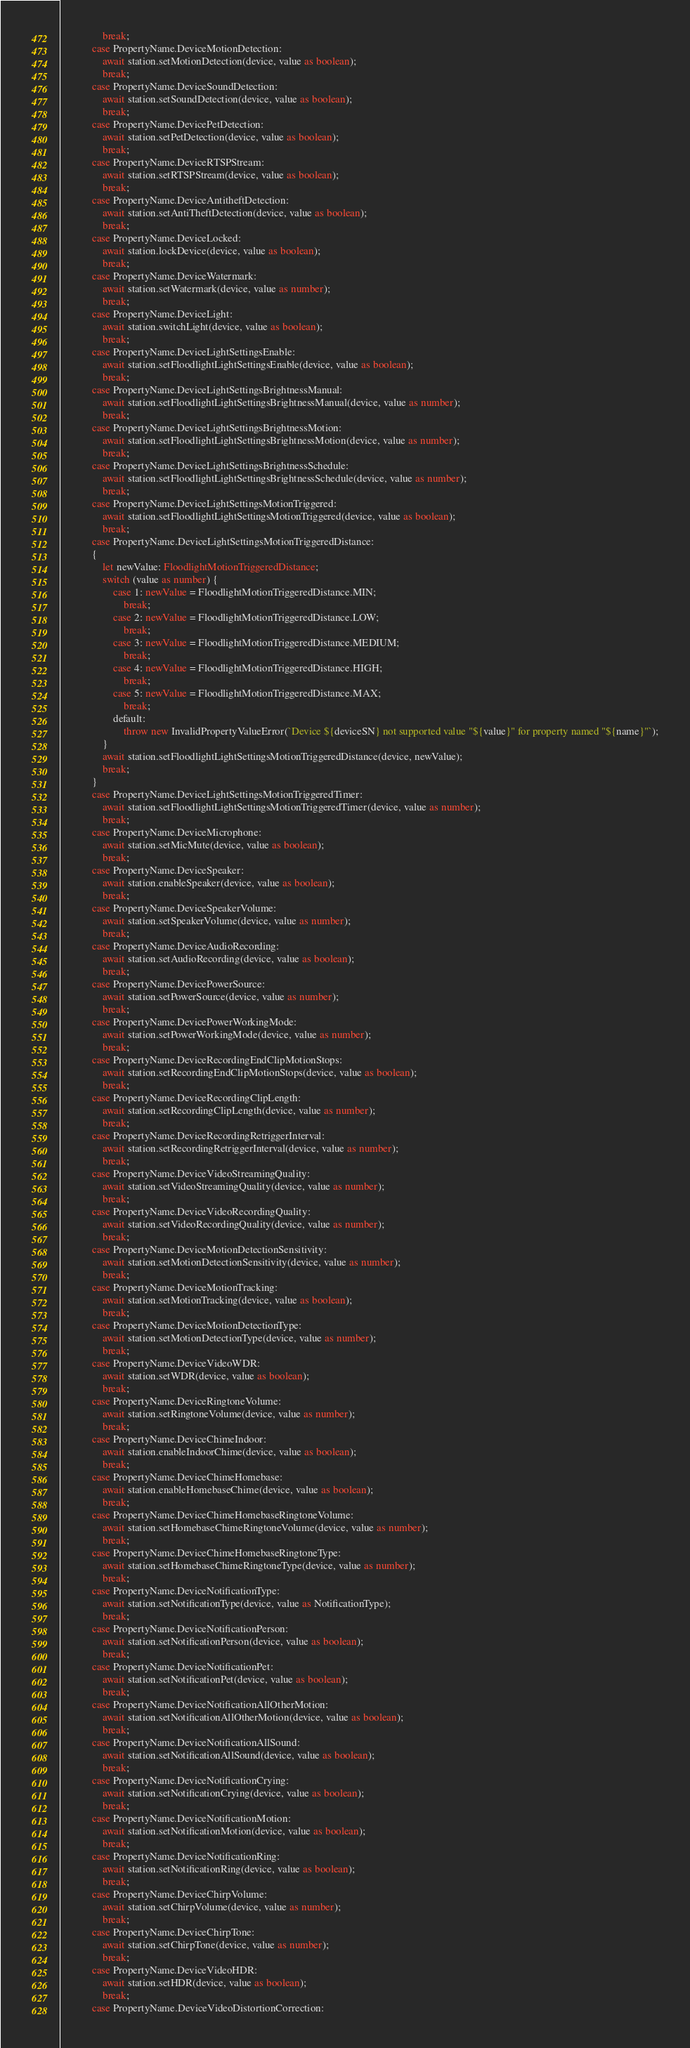Convert code to text. <code><loc_0><loc_0><loc_500><loc_500><_TypeScript_>                break;
            case PropertyName.DeviceMotionDetection:
                await station.setMotionDetection(device, value as boolean);
                break;
            case PropertyName.DeviceSoundDetection:
                await station.setSoundDetection(device, value as boolean);
                break;
            case PropertyName.DevicePetDetection:
                await station.setPetDetection(device, value as boolean);
                break;
            case PropertyName.DeviceRTSPStream:
                await station.setRTSPStream(device, value as boolean);
                break;
            case PropertyName.DeviceAntitheftDetection:
                await station.setAntiTheftDetection(device, value as boolean);
                break;
            case PropertyName.DeviceLocked:
                await station.lockDevice(device, value as boolean);
                break;
            case PropertyName.DeviceWatermark:
                await station.setWatermark(device, value as number);
                break;
            case PropertyName.DeviceLight:
                await station.switchLight(device, value as boolean);
                break;
            case PropertyName.DeviceLightSettingsEnable:
                await station.setFloodlightLightSettingsEnable(device, value as boolean);
                break;
            case PropertyName.DeviceLightSettingsBrightnessManual:
                await station.setFloodlightLightSettingsBrightnessManual(device, value as number);
                break;
            case PropertyName.DeviceLightSettingsBrightnessMotion:
                await station.setFloodlightLightSettingsBrightnessMotion(device, value as number);
                break;
            case PropertyName.DeviceLightSettingsBrightnessSchedule:
                await station.setFloodlightLightSettingsBrightnessSchedule(device, value as number);
                break;
            case PropertyName.DeviceLightSettingsMotionTriggered:
                await station.setFloodlightLightSettingsMotionTriggered(device, value as boolean);
                break;
            case PropertyName.DeviceLightSettingsMotionTriggeredDistance:
            {
                let newValue: FloodlightMotionTriggeredDistance;
                switch (value as number) {
                    case 1: newValue = FloodlightMotionTriggeredDistance.MIN;
                        break;
                    case 2: newValue = FloodlightMotionTriggeredDistance.LOW;
                        break;
                    case 3: newValue = FloodlightMotionTriggeredDistance.MEDIUM;
                        break;
                    case 4: newValue = FloodlightMotionTriggeredDistance.HIGH;
                        break;
                    case 5: newValue = FloodlightMotionTriggeredDistance.MAX;
                        break;
                    default:
                        throw new InvalidPropertyValueError(`Device ${deviceSN} not supported value "${value}" for property named "${name}"`);
                }
                await station.setFloodlightLightSettingsMotionTriggeredDistance(device, newValue);
                break;
            }
            case PropertyName.DeviceLightSettingsMotionTriggeredTimer:
                await station.setFloodlightLightSettingsMotionTriggeredTimer(device, value as number);
                break;
            case PropertyName.DeviceMicrophone:
                await station.setMicMute(device, value as boolean);
                break;
            case PropertyName.DeviceSpeaker:
                await station.enableSpeaker(device, value as boolean);
                break;
            case PropertyName.DeviceSpeakerVolume:
                await station.setSpeakerVolume(device, value as number);
                break;
            case PropertyName.DeviceAudioRecording:
                await station.setAudioRecording(device, value as boolean);
                break;
            case PropertyName.DevicePowerSource:
                await station.setPowerSource(device, value as number);
                break;
            case PropertyName.DevicePowerWorkingMode:
                await station.setPowerWorkingMode(device, value as number);
                break;
            case PropertyName.DeviceRecordingEndClipMotionStops:
                await station.setRecordingEndClipMotionStops(device, value as boolean);
                break;
            case PropertyName.DeviceRecordingClipLength:
                await station.setRecordingClipLength(device, value as number);
                break;
            case PropertyName.DeviceRecordingRetriggerInterval:
                await station.setRecordingRetriggerInterval(device, value as number);
                break;
            case PropertyName.DeviceVideoStreamingQuality:
                await station.setVideoStreamingQuality(device, value as number);
                break;
            case PropertyName.DeviceVideoRecordingQuality:
                await station.setVideoRecordingQuality(device, value as number);
                break;
            case PropertyName.DeviceMotionDetectionSensitivity:
                await station.setMotionDetectionSensitivity(device, value as number);
                break;
            case PropertyName.DeviceMotionTracking:
                await station.setMotionTracking(device, value as boolean);
                break;
            case PropertyName.DeviceMotionDetectionType:
                await station.setMotionDetectionType(device, value as number);
                break;
            case PropertyName.DeviceVideoWDR:
                await station.setWDR(device, value as boolean);
                break;
            case PropertyName.DeviceRingtoneVolume:
                await station.setRingtoneVolume(device, value as number);
                break;
            case PropertyName.DeviceChimeIndoor:
                await station.enableIndoorChime(device, value as boolean);
                break;
            case PropertyName.DeviceChimeHomebase:
                await station.enableHomebaseChime(device, value as boolean);
                break;
            case PropertyName.DeviceChimeHomebaseRingtoneVolume:
                await station.setHomebaseChimeRingtoneVolume(device, value as number);
                break;
            case PropertyName.DeviceChimeHomebaseRingtoneType:
                await station.setHomebaseChimeRingtoneType(device, value as number);
                break;
            case PropertyName.DeviceNotificationType:
                await station.setNotificationType(device, value as NotificationType);
                break;
            case PropertyName.DeviceNotificationPerson:
                await station.setNotificationPerson(device, value as boolean);
                break;
            case PropertyName.DeviceNotificationPet:
                await station.setNotificationPet(device, value as boolean);
                break;
            case PropertyName.DeviceNotificationAllOtherMotion:
                await station.setNotificationAllOtherMotion(device, value as boolean);
                break;
            case PropertyName.DeviceNotificationAllSound:
                await station.setNotificationAllSound(device, value as boolean);
                break;
            case PropertyName.DeviceNotificationCrying:
                await station.setNotificationCrying(device, value as boolean);
                break;
            case PropertyName.DeviceNotificationMotion:
                await station.setNotificationMotion(device, value as boolean);
                break;
            case PropertyName.DeviceNotificationRing:
                await station.setNotificationRing(device, value as boolean);
                break;
            case PropertyName.DeviceChirpVolume:
                await station.setChirpVolume(device, value as number);
                break;
            case PropertyName.DeviceChirpTone:
                await station.setChirpTone(device, value as number);
                break;
            case PropertyName.DeviceVideoHDR:
                await station.setHDR(device, value as boolean);
                break;
            case PropertyName.DeviceVideoDistortionCorrection:</code> 